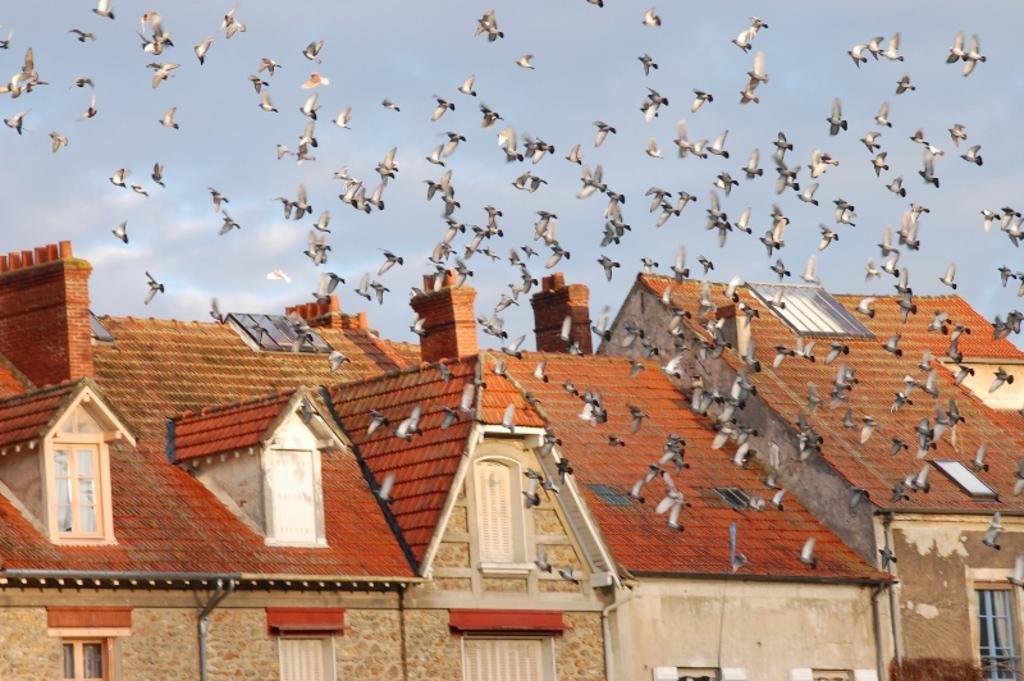Please provide a concise description of this image. In this image, there are a few houses, birds. We can also see the sky. 